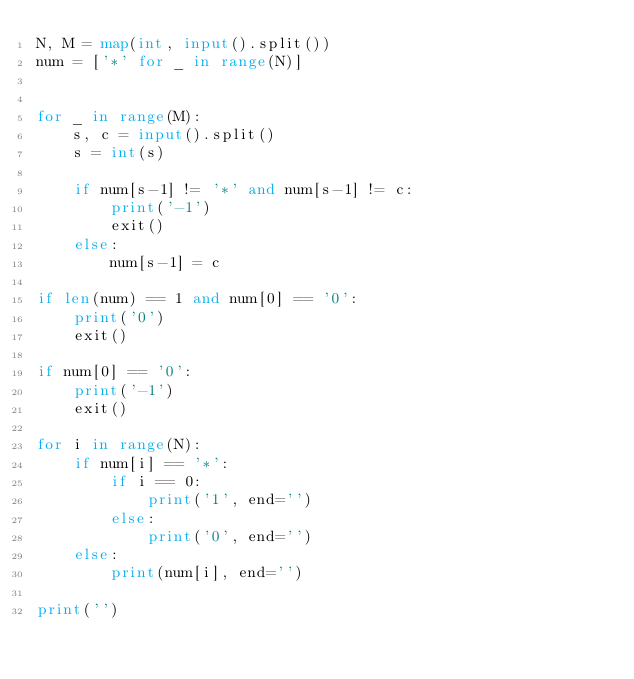Convert code to text. <code><loc_0><loc_0><loc_500><loc_500><_Python_>N, M = map(int, input().split())
num = ['*' for _ in range(N)]


for _ in range(M):
    s, c = input().split()
    s = int(s)

    if num[s-1] != '*' and num[s-1] != c:
        print('-1')
        exit()
    else:
        num[s-1] = c

if len(num) == 1 and num[0] == '0':
    print('0')
    exit()

if num[0] == '0':
    print('-1')
    exit()

for i in range(N):
    if num[i] == '*':
        if i == 0:
            print('1', end='')
        else:
            print('0', end='')
    else:
        print(num[i], end='')

print('')
</code> 